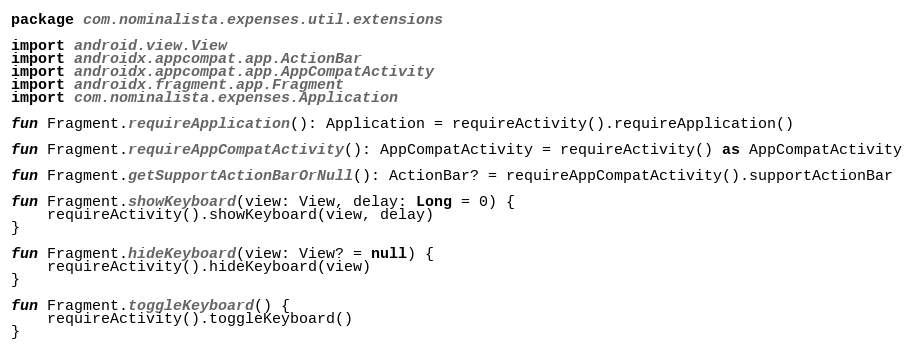Convert code to text. <code><loc_0><loc_0><loc_500><loc_500><_Kotlin_>package com.nominalista.expenses.util.extensions

import android.view.View
import androidx.appcompat.app.ActionBar
import androidx.appcompat.app.AppCompatActivity
import androidx.fragment.app.Fragment
import com.nominalista.expenses.Application

fun Fragment.requireApplication(): Application = requireActivity().requireApplication()

fun Fragment.requireAppCompatActivity(): AppCompatActivity = requireActivity() as AppCompatActivity

fun Fragment.getSupportActionBarOrNull(): ActionBar? = requireAppCompatActivity().supportActionBar

fun Fragment.showKeyboard(view: View, delay: Long = 0) {
    requireActivity().showKeyboard(view, delay)
}

fun Fragment.hideKeyboard(view: View? = null) {
    requireActivity().hideKeyboard(view)
}

fun Fragment.toggleKeyboard() {
    requireActivity().toggleKeyboard()
}</code> 